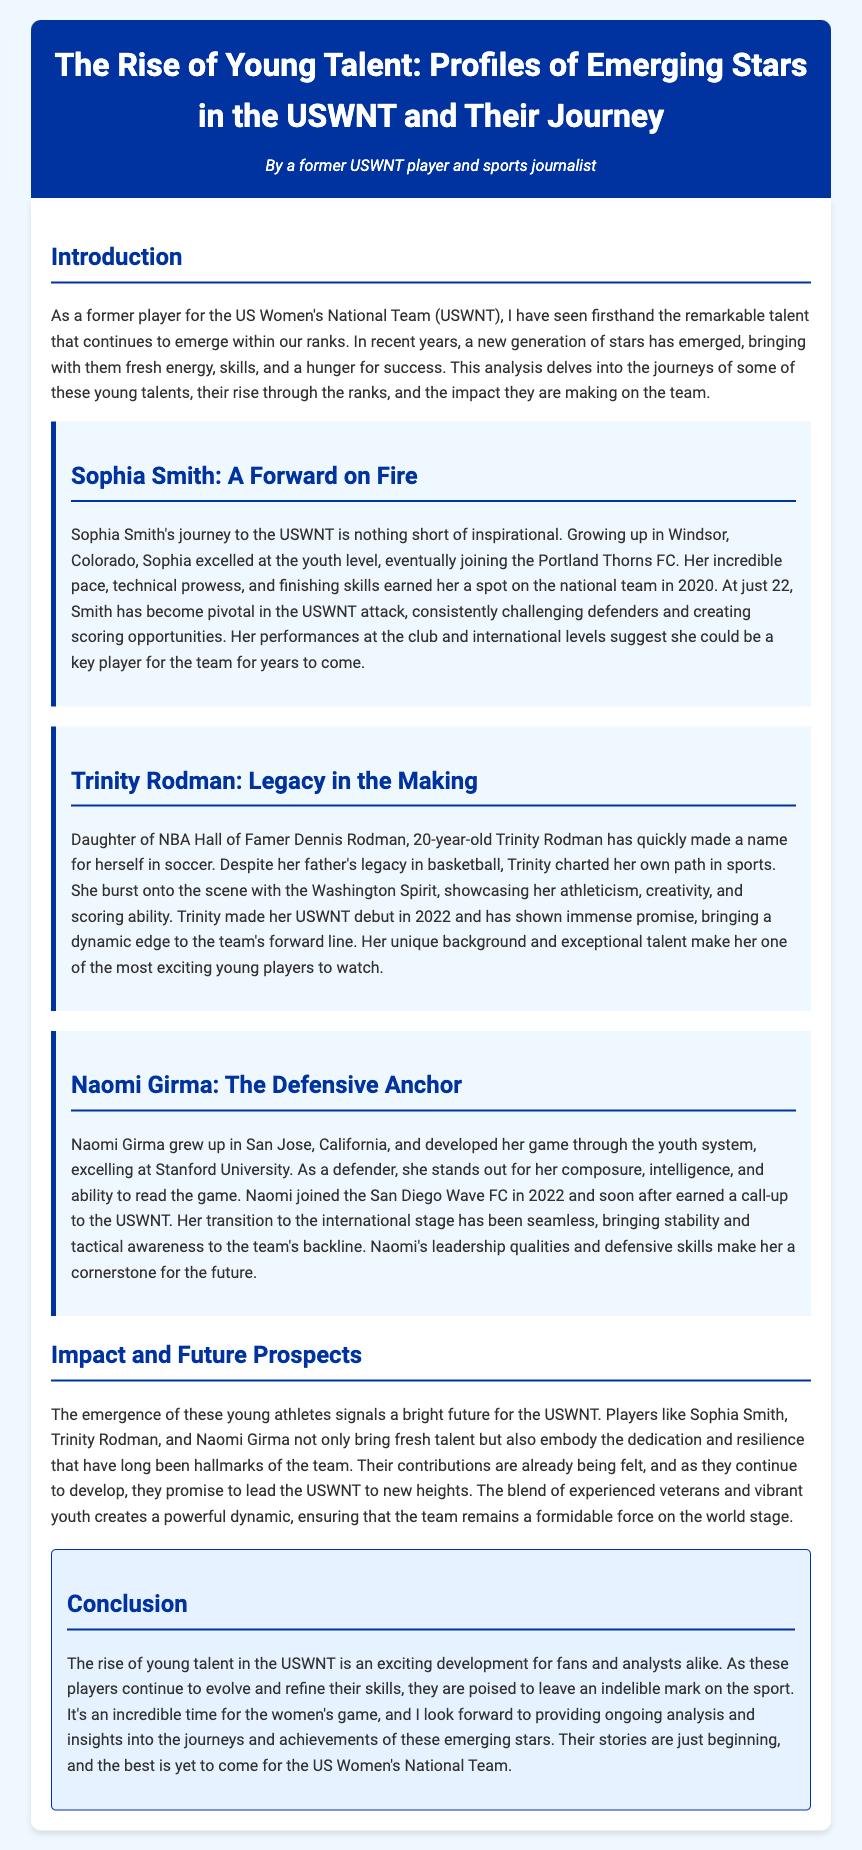What is the title of the document? The title of the document is mentioned at the top of the rendered content.
Answer: The Rise of Young Talent: Profiles of Emerging Stars in the USWNT and Their Journey Who is the author of the document? The author is introduced in the header section of the document.
Answer: A former USWNT player and sports journalist How old is Sophia Smith? Sophia's age is provided in her profile section of the document.
Answer: 22 What club did Trinity Rodman play for? The club for which Trinity plays is mentioned in her profile section.
Answer: Washington Spirit In what year did Naomi Girma earn a call-up to the USWNT? The year Naomi earned her call-up is specified in her profile.
Answer: 2022 What impact do the young athletes have on the USWNT? The impact of the emerging talents on the team is highlighted in the document's impact section.
Answer: Bright future Which player is described as the "Defensive Anchor"? This phrase is part of the heading describing Naomi Girma.
Answer: Naomi Girma What is the main theme of the document? The main theme is outlined in the introduction and conclusion.
Answer: The rise of young talent What qualities do the young talents bring to the USWNT? The document describes their contributions in the impact section.
Answer: Dedication and resilience 